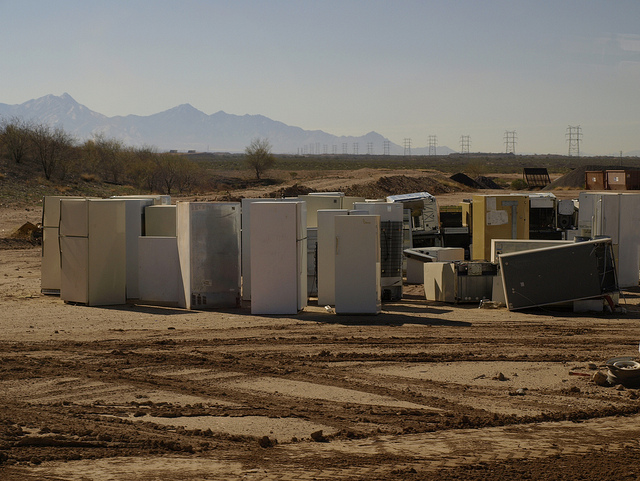<image>Are any of these refrigerators working now? It is unknown if any of these refrigerators are working now. What city is this? It is unknown what city this is. The answer could be any city from Detroit to Los Angeles. Are any of these refrigerators working now? None of these refrigerators are working now. What city is this? I don't know what city this is. It could be any of 'none', 'refrigerator city', 'detroit', 'philly', 'nevada', 'atlanta', 'unknown', 'los angeles', or 'denver'. 